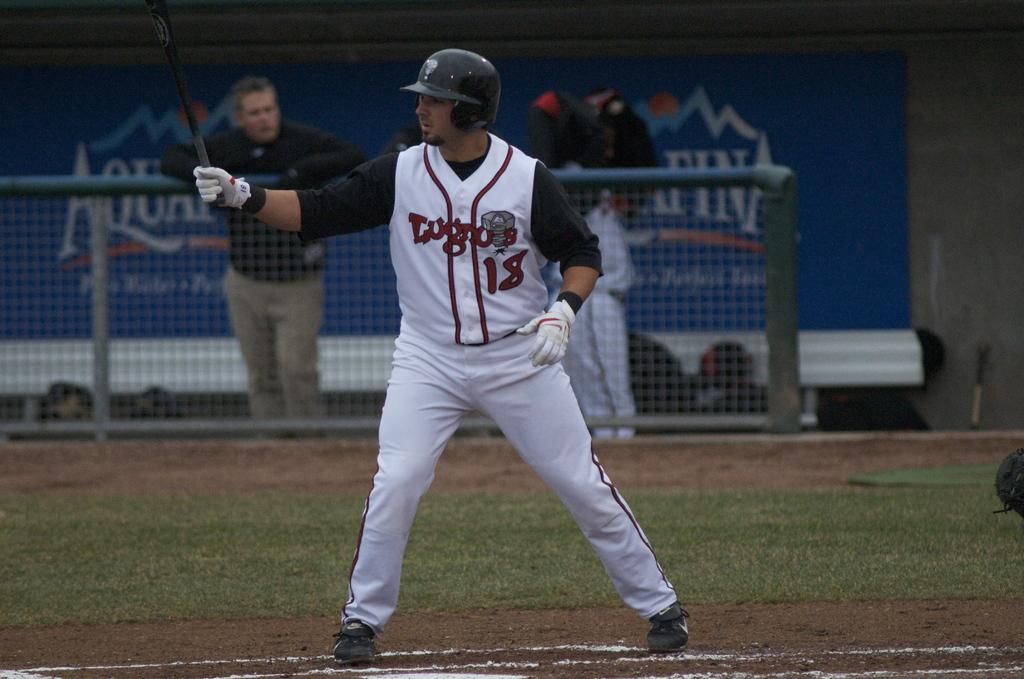<image>
Share a concise interpretation of the image provided. A man stands behind a fence where there is an Aquafina banner displayed. 